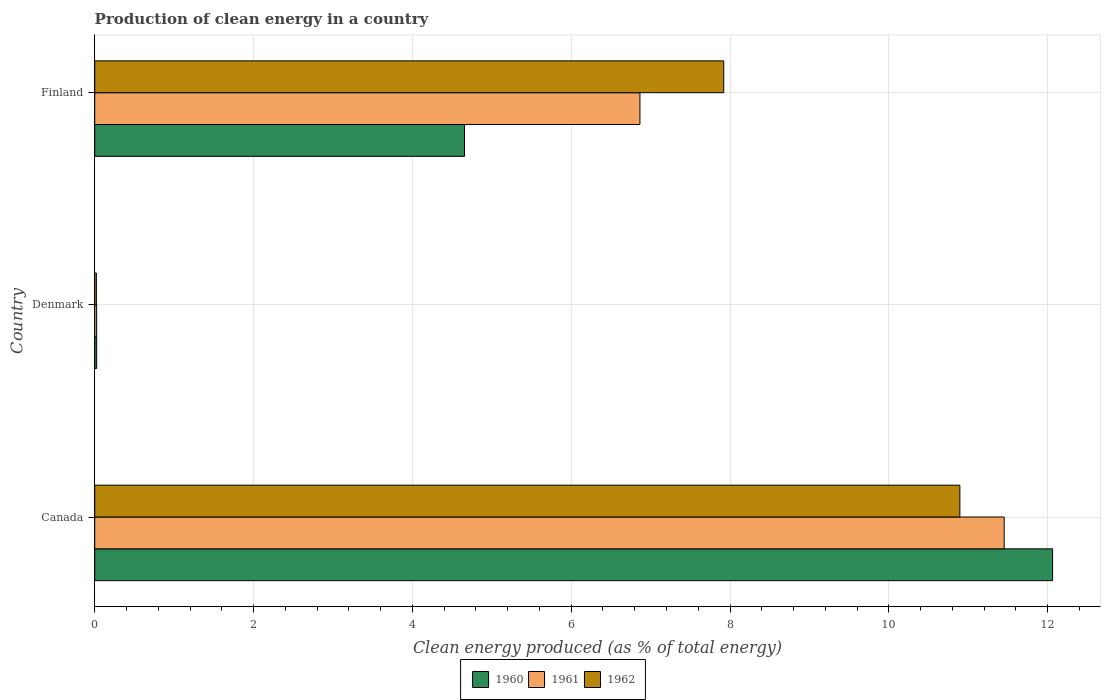How many groups of bars are there?
Offer a very short reply. 3. How many bars are there on the 2nd tick from the top?
Your response must be concise. 3. How many bars are there on the 2nd tick from the bottom?
Offer a very short reply. 3. What is the percentage of clean energy produced in 1960 in Canada?
Your answer should be compact. 12.06. Across all countries, what is the maximum percentage of clean energy produced in 1960?
Provide a succinct answer. 12.06. Across all countries, what is the minimum percentage of clean energy produced in 1961?
Make the answer very short. 0.02. What is the total percentage of clean energy produced in 1962 in the graph?
Your answer should be very brief. 18.84. What is the difference between the percentage of clean energy produced in 1960 in Canada and that in Denmark?
Give a very brief answer. 12.04. What is the difference between the percentage of clean energy produced in 1961 in Denmark and the percentage of clean energy produced in 1962 in Finland?
Make the answer very short. -7.9. What is the average percentage of clean energy produced in 1960 per country?
Your answer should be very brief. 5.58. What is the difference between the percentage of clean energy produced in 1960 and percentage of clean energy produced in 1961 in Finland?
Offer a terse response. -2.21. What is the ratio of the percentage of clean energy produced in 1960 in Denmark to that in Finland?
Give a very brief answer. 0.01. Is the difference between the percentage of clean energy produced in 1960 in Canada and Denmark greater than the difference between the percentage of clean energy produced in 1961 in Canada and Denmark?
Offer a very short reply. Yes. What is the difference between the highest and the second highest percentage of clean energy produced in 1960?
Provide a short and direct response. 7.41. What is the difference between the highest and the lowest percentage of clean energy produced in 1962?
Your response must be concise. 10.87. What does the 3rd bar from the bottom in Canada represents?
Provide a short and direct response. 1962. How many countries are there in the graph?
Your answer should be very brief. 3. Does the graph contain any zero values?
Offer a terse response. No. Does the graph contain grids?
Make the answer very short. Yes. What is the title of the graph?
Your answer should be very brief. Production of clean energy in a country. What is the label or title of the X-axis?
Provide a succinct answer. Clean energy produced (as % of total energy). What is the Clean energy produced (as % of total energy) in 1960 in Canada?
Offer a very short reply. 12.06. What is the Clean energy produced (as % of total energy) in 1961 in Canada?
Keep it short and to the point. 11.45. What is the Clean energy produced (as % of total energy) of 1962 in Canada?
Provide a succinct answer. 10.89. What is the Clean energy produced (as % of total energy) in 1960 in Denmark?
Keep it short and to the point. 0.02. What is the Clean energy produced (as % of total energy) of 1961 in Denmark?
Ensure brevity in your answer.  0.02. What is the Clean energy produced (as % of total energy) of 1962 in Denmark?
Offer a very short reply. 0.02. What is the Clean energy produced (as % of total energy) in 1960 in Finland?
Make the answer very short. 4.66. What is the Clean energy produced (as % of total energy) of 1961 in Finland?
Provide a succinct answer. 6.87. What is the Clean energy produced (as % of total energy) in 1962 in Finland?
Keep it short and to the point. 7.92. Across all countries, what is the maximum Clean energy produced (as % of total energy) in 1960?
Give a very brief answer. 12.06. Across all countries, what is the maximum Clean energy produced (as % of total energy) in 1961?
Offer a terse response. 11.45. Across all countries, what is the maximum Clean energy produced (as % of total energy) in 1962?
Offer a very short reply. 10.89. Across all countries, what is the minimum Clean energy produced (as % of total energy) in 1960?
Your response must be concise. 0.02. Across all countries, what is the minimum Clean energy produced (as % of total energy) of 1961?
Your response must be concise. 0.02. Across all countries, what is the minimum Clean energy produced (as % of total energy) of 1962?
Provide a short and direct response. 0.02. What is the total Clean energy produced (as % of total energy) of 1960 in the graph?
Keep it short and to the point. 16.74. What is the total Clean energy produced (as % of total energy) in 1961 in the graph?
Offer a very short reply. 18.34. What is the total Clean energy produced (as % of total energy) in 1962 in the graph?
Provide a short and direct response. 18.84. What is the difference between the Clean energy produced (as % of total energy) in 1960 in Canada and that in Denmark?
Your answer should be very brief. 12.04. What is the difference between the Clean energy produced (as % of total energy) of 1961 in Canada and that in Denmark?
Your answer should be very brief. 11.43. What is the difference between the Clean energy produced (as % of total energy) of 1962 in Canada and that in Denmark?
Your answer should be compact. 10.87. What is the difference between the Clean energy produced (as % of total energy) of 1960 in Canada and that in Finland?
Provide a short and direct response. 7.41. What is the difference between the Clean energy produced (as % of total energy) in 1961 in Canada and that in Finland?
Provide a succinct answer. 4.59. What is the difference between the Clean energy produced (as % of total energy) of 1962 in Canada and that in Finland?
Provide a succinct answer. 2.97. What is the difference between the Clean energy produced (as % of total energy) in 1960 in Denmark and that in Finland?
Keep it short and to the point. -4.63. What is the difference between the Clean energy produced (as % of total energy) of 1961 in Denmark and that in Finland?
Give a very brief answer. -6.84. What is the difference between the Clean energy produced (as % of total energy) in 1962 in Denmark and that in Finland?
Your answer should be very brief. -7.9. What is the difference between the Clean energy produced (as % of total energy) in 1960 in Canada and the Clean energy produced (as % of total energy) in 1961 in Denmark?
Your answer should be very brief. 12.04. What is the difference between the Clean energy produced (as % of total energy) in 1960 in Canada and the Clean energy produced (as % of total energy) in 1962 in Denmark?
Keep it short and to the point. 12.04. What is the difference between the Clean energy produced (as % of total energy) of 1961 in Canada and the Clean energy produced (as % of total energy) of 1962 in Denmark?
Offer a terse response. 11.43. What is the difference between the Clean energy produced (as % of total energy) in 1960 in Canada and the Clean energy produced (as % of total energy) in 1961 in Finland?
Your answer should be compact. 5.2. What is the difference between the Clean energy produced (as % of total energy) of 1960 in Canada and the Clean energy produced (as % of total energy) of 1962 in Finland?
Your answer should be very brief. 4.14. What is the difference between the Clean energy produced (as % of total energy) in 1961 in Canada and the Clean energy produced (as % of total energy) in 1962 in Finland?
Offer a terse response. 3.53. What is the difference between the Clean energy produced (as % of total energy) of 1960 in Denmark and the Clean energy produced (as % of total energy) of 1961 in Finland?
Your answer should be compact. -6.84. What is the difference between the Clean energy produced (as % of total energy) of 1960 in Denmark and the Clean energy produced (as % of total energy) of 1962 in Finland?
Offer a very short reply. -7.9. What is the difference between the Clean energy produced (as % of total energy) in 1961 in Denmark and the Clean energy produced (as % of total energy) in 1962 in Finland?
Your response must be concise. -7.9. What is the average Clean energy produced (as % of total energy) of 1960 per country?
Offer a very short reply. 5.58. What is the average Clean energy produced (as % of total energy) of 1961 per country?
Offer a very short reply. 6.11. What is the average Clean energy produced (as % of total energy) of 1962 per country?
Your answer should be very brief. 6.28. What is the difference between the Clean energy produced (as % of total energy) in 1960 and Clean energy produced (as % of total energy) in 1961 in Canada?
Offer a terse response. 0.61. What is the difference between the Clean energy produced (as % of total energy) in 1960 and Clean energy produced (as % of total energy) in 1962 in Canada?
Ensure brevity in your answer.  1.17. What is the difference between the Clean energy produced (as % of total energy) in 1961 and Clean energy produced (as % of total energy) in 1962 in Canada?
Keep it short and to the point. 0.56. What is the difference between the Clean energy produced (as % of total energy) of 1960 and Clean energy produced (as % of total energy) of 1961 in Denmark?
Offer a very short reply. 0. What is the difference between the Clean energy produced (as % of total energy) of 1960 and Clean energy produced (as % of total energy) of 1962 in Denmark?
Your response must be concise. 0. What is the difference between the Clean energy produced (as % of total energy) of 1961 and Clean energy produced (as % of total energy) of 1962 in Denmark?
Give a very brief answer. 0. What is the difference between the Clean energy produced (as % of total energy) in 1960 and Clean energy produced (as % of total energy) in 1961 in Finland?
Your answer should be compact. -2.21. What is the difference between the Clean energy produced (as % of total energy) in 1960 and Clean energy produced (as % of total energy) in 1962 in Finland?
Offer a terse response. -3.26. What is the difference between the Clean energy produced (as % of total energy) of 1961 and Clean energy produced (as % of total energy) of 1962 in Finland?
Make the answer very short. -1.06. What is the ratio of the Clean energy produced (as % of total energy) in 1960 in Canada to that in Denmark?
Your answer should be very brief. 494.07. What is the ratio of the Clean energy produced (as % of total energy) of 1961 in Canada to that in Denmark?
Give a very brief answer. 477.92. What is the ratio of the Clean energy produced (as % of total energy) in 1962 in Canada to that in Denmark?
Offer a very short reply. 520.01. What is the ratio of the Clean energy produced (as % of total energy) in 1960 in Canada to that in Finland?
Offer a terse response. 2.59. What is the ratio of the Clean energy produced (as % of total energy) of 1961 in Canada to that in Finland?
Your answer should be very brief. 1.67. What is the ratio of the Clean energy produced (as % of total energy) of 1962 in Canada to that in Finland?
Your answer should be compact. 1.38. What is the ratio of the Clean energy produced (as % of total energy) in 1960 in Denmark to that in Finland?
Your response must be concise. 0.01. What is the ratio of the Clean energy produced (as % of total energy) of 1961 in Denmark to that in Finland?
Provide a succinct answer. 0. What is the ratio of the Clean energy produced (as % of total energy) of 1962 in Denmark to that in Finland?
Provide a succinct answer. 0. What is the difference between the highest and the second highest Clean energy produced (as % of total energy) of 1960?
Provide a short and direct response. 7.41. What is the difference between the highest and the second highest Clean energy produced (as % of total energy) of 1961?
Your answer should be compact. 4.59. What is the difference between the highest and the second highest Clean energy produced (as % of total energy) of 1962?
Your answer should be compact. 2.97. What is the difference between the highest and the lowest Clean energy produced (as % of total energy) in 1960?
Make the answer very short. 12.04. What is the difference between the highest and the lowest Clean energy produced (as % of total energy) of 1961?
Your answer should be very brief. 11.43. What is the difference between the highest and the lowest Clean energy produced (as % of total energy) of 1962?
Your answer should be compact. 10.87. 